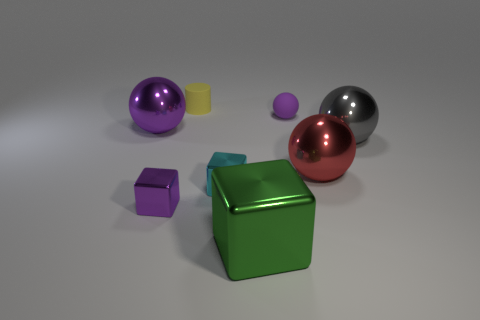Subtract all purple shiny blocks. How many blocks are left? 2 Subtract all red balls. How many balls are left? 3 Add 1 green things. How many objects exist? 9 Subtract all blocks. How many objects are left? 5 Subtract all cyan cubes. How many purple balls are left? 2 Subtract 0 gray blocks. How many objects are left? 8 Subtract 1 cylinders. How many cylinders are left? 0 Subtract all yellow balls. Subtract all cyan blocks. How many balls are left? 4 Subtract all tiny yellow rubber things. Subtract all large green rubber blocks. How many objects are left? 7 Add 4 small cyan metallic cubes. How many small cyan metallic cubes are left? 5 